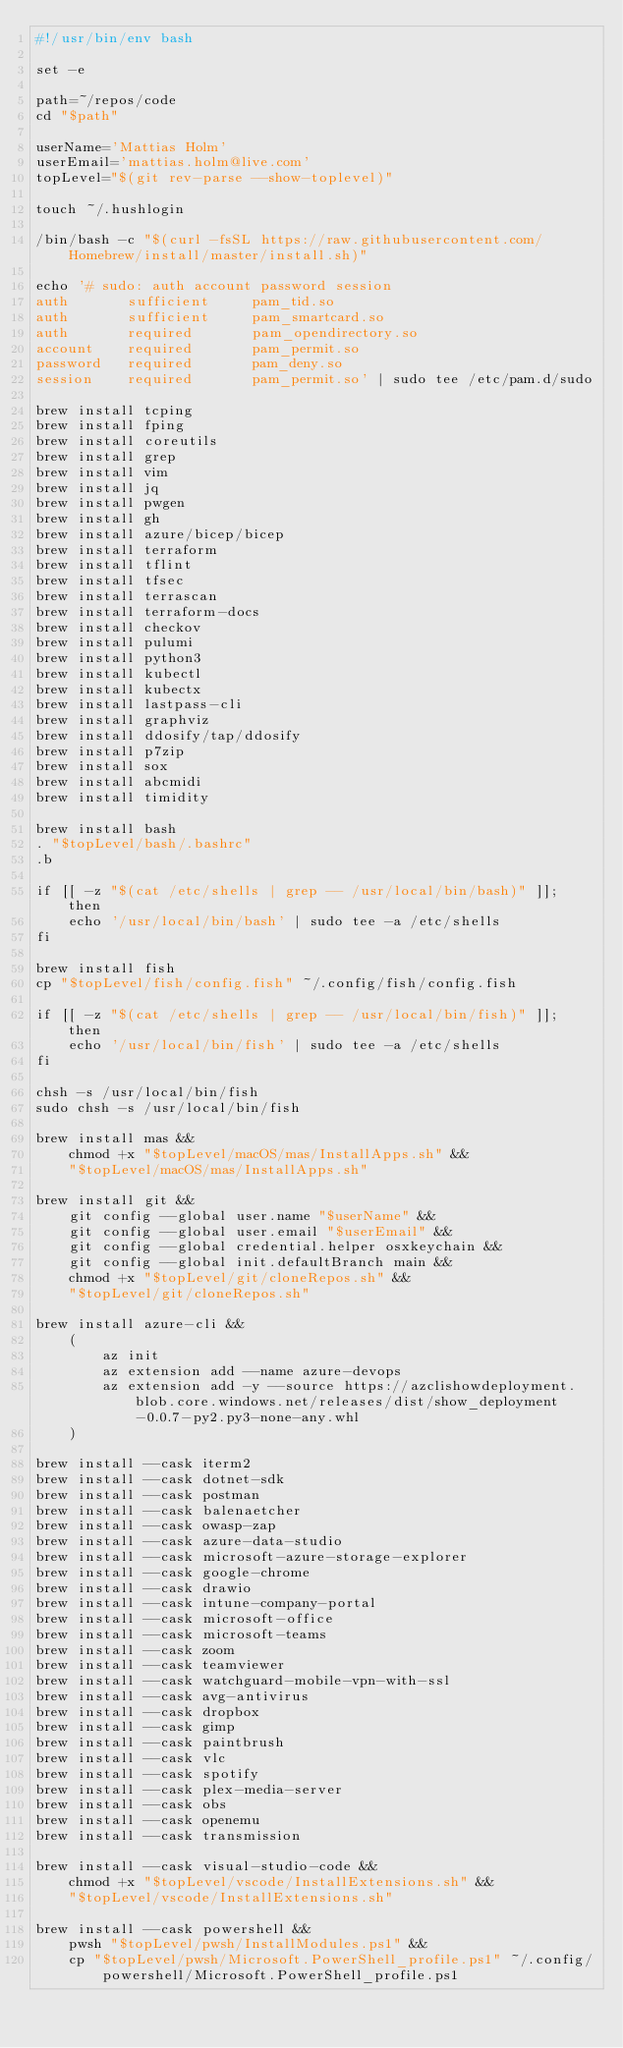Convert code to text. <code><loc_0><loc_0><loc_500><loc_500><_Bash_>#!/usr/bin/env bash

set -e

path=~/repos/code
cd "$path"

userName='Mattias Holm'
userEmail='mattias.holm@live.com'
topLevel="$(git rev-parse --show-toplevel)"

touch ~/.hushlogin

/bin/bash -c "$(curl -fsSL https://raw.githubusercontent.com/Homebrew/install/master/install.sh)"

echo '# sudo: auth account password session
auth       sufficient     pam_tid.so
auth       sufficient     pam_smartcard.so
auth       required       pam_opendirectory.so
account    required       pam_permit.so
password   required       pam_deny.so
session    required       pam_permit.so' | sudo tee /etc/pam.d/sudo

brew install tcping
brew install fping
brew install coreutils
brew install grep
brew install vim
brew install jq
brew install pwgen
brew install gh
brew install azure/bicep/bicep
brew install terraform
brew install tflint
brew install tfsec
brew install terrascan
brew install terraform-docs
brew install checkov
brew install pulumi
brew install python3
brew install kubectl
brew install kubectx
brew install lastpass-cli
brew install graphviz
brew install ddosify/tap/ddosify
brew install p7zip
brew install sox
brew install abcmidi
brew install timidity

brew install bash
. "$topLevel/bash/.bashrc"
.b

if [[ -z "$(cat /etc/shells | grep -- /usr/local/bin/bash)" ]]; then
    echo '/usr/local/bin/bash' | sudo tee -a /etc/shells
fi

brew install fish
cp "$topLevel/fish/config.fish" ~/.config/fish/config.fish

if [[ -z "$(cat /etc/shells | grep -- /usr/local/bin/fish)" ]]; then
    echo '/usr/local/bin/fish' | sudo tee -a /etc/shells
fi

chsh -s /usr/local/bin/fish
sudo chsh -s /usr/local/bin/fish

brew install mas &&
    chmod +x "$topLevel/macOS/mas/InstallApps.sh" &&
    "$topLevel/macOS/mas/InstallApps.sh"

brew install git &&
    git config --global user.name "$userName" &&
    git config --global user.email "$userEmail" &&
    git config --global credential.helper osxkeychain &&
    git config --global init.defaultBranch main &&
    chmod +x "$topLevel/git/cloneRepos.sh" &&
    "$topLevel/git/cloneRepos.sh"

brew install azure-cli &&
    (
        az init
        az extension add --name azure-devops
        az extension add -y --source https://azclishowdeployment.blob.core.windows.net/releases/dist/show_deployment-0.0.7-py2.py3-none-any.whl
    )

brew install --cask iterm2
brew install --cask dotnet-sdk
brew install --cask postman
brew install --cask balenaetcher
brew install --cask owasp-zap
brew install --cask azure-data-studio
brew install --cask microsoft-azure-storage-explorer
brew install --cask google-chrome
brew install --cask drawio
brew install --cask intune-company-portal
brew install --cask microsoft-office
brew install --cask microsoft-teams
brew install --cask zoom
brew install --cask teamviewer
brew install --cask watchguard-mobile-vpn-with-ssl
brew install --cask avg-antivirus
brew install --cask dropbox
brew install --cask gimp
brew install --cask paintbrush
brew install --cask vlc
brew install --cask spotify
brew install --cask plex-media-server
brew install --cask obs
brew install --cask openemu
brew install --cask transmission

brew install --cask visual-studio-code &&
    chmod +x "$topLevel/vscode/InstallExtensions.sh" &&
    "$topLevel/vscode/InstallExtensions.sh"

brew install --cask powershell &&
    pwsh "$topLevel/pwsh/InstallModules.ps1" &&
    cp "$topLevel/pwsh/Microsoft.PowerShell_profile.ps1" ~/.config/powershell/Microsoft.PowerShell_profile.ps1
</code> 